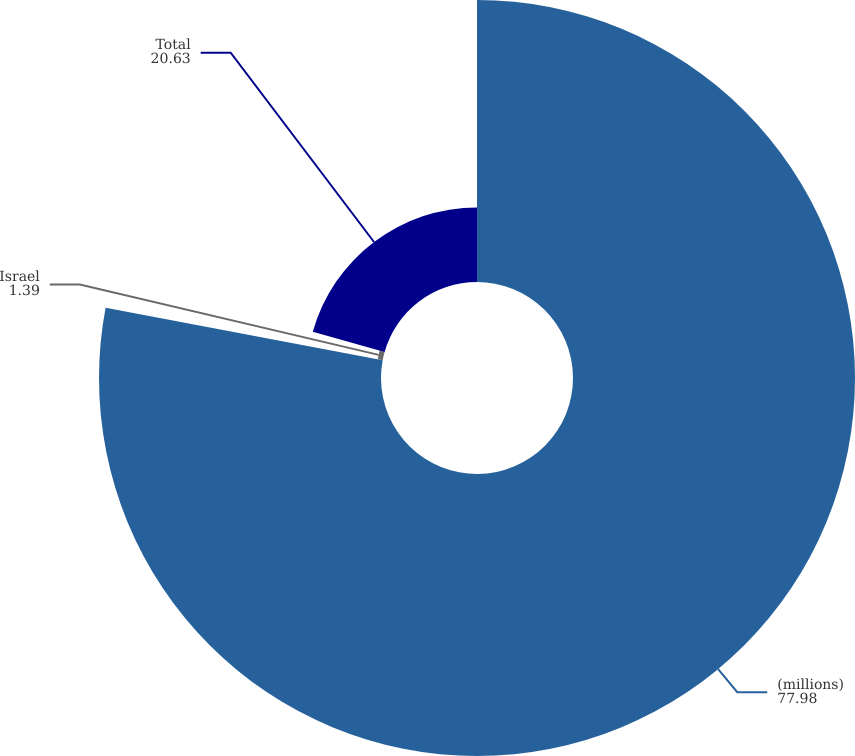Convert chart to OTSL. <chart><loc_0><loc_0><loc_500><loc_500><pie_chart><fcel>(millions)<fcel>Israel<fcel>Total<nl><fcel>77.98%<fcel>1.39%<fcel>20.63%<nl></chart> 